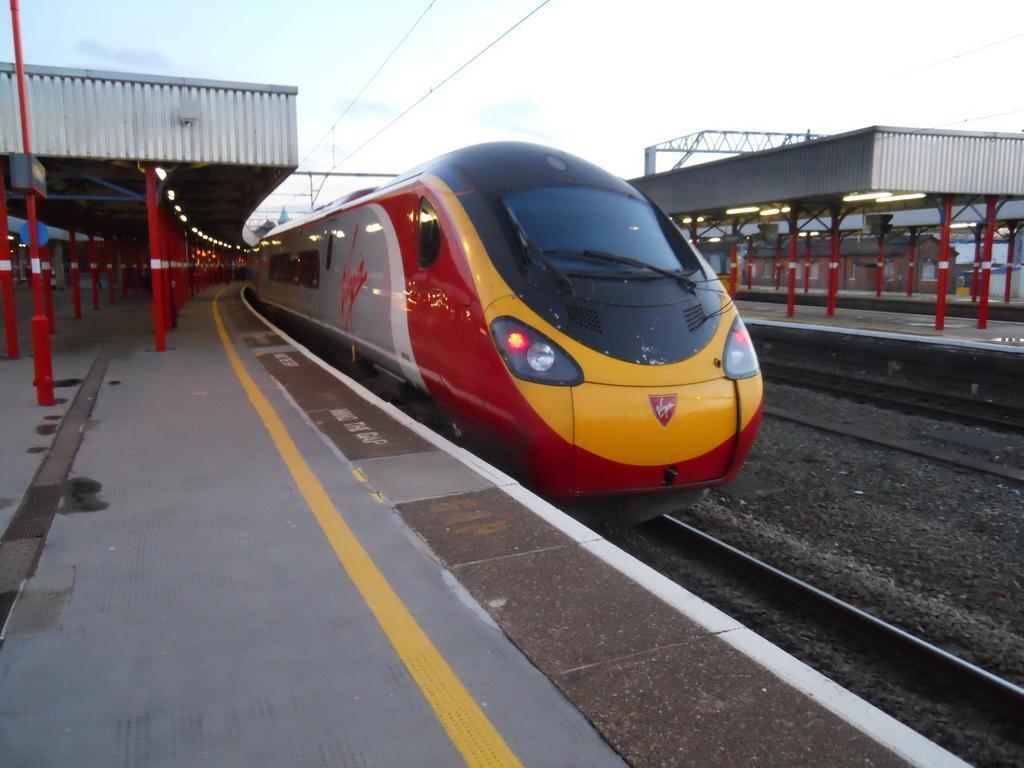Could you give a brief overview of what you see in this image? In this picture, we see a train in red, grey, yellow and black color is moving on the railway tracks. Behind the train we see an electric pole. On either side of the picture, we see red color moles on the platform. At the top of the picture, we see the wires and the sky. This picture is clicked in the railway station. 